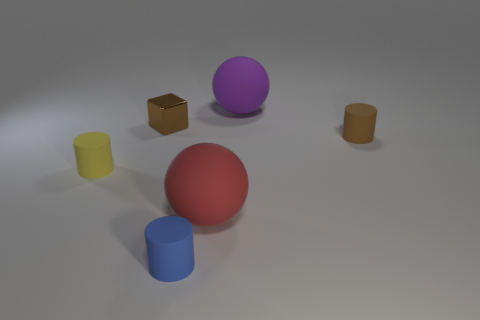There is a cylinder that is on the left side of the shiny cube; is its size the same as the brown cylinder?
Your answer should be compact. Yes. Are there more brown blocks that are on the left side of the brown cylinder than big gray metal balls?
Your response must be concise. Yes. There is a tiny matte cylinder behind the yellow matte cylinder; how many matte objects are to the left of it?
Provide a succinct answer. 4. Are there fewer big purple things that are on the left side of the purple object than green matte cylinders?
Give a very brief answer. No. Are there any large red rubber balls that are in front of the small rubber object to the right of the small cylinder that is in front of the red matte sphere?
Offer a very short reply. Yes. Do the large red sphere and the brown object left of the blue thing have the same material?
Ensure brevity in your answer.  No. What color is the large thing that is behind the matte thing on the left side of the blue rubber thing?
Ensure brevity in your answer.  Purple. Are there any rubber objects of the same color as the metallic object?
Make the answer very short. Yes. There is a matte cylinder that is behind the matte object that is left of the small rubber cylinder in front of the red matte thing; how big is it?
Your answer should be very brief. Small. There is a large red rubber thing; does it have the same shape as the object in front of the red sphere?
Your response must be concise. No. 